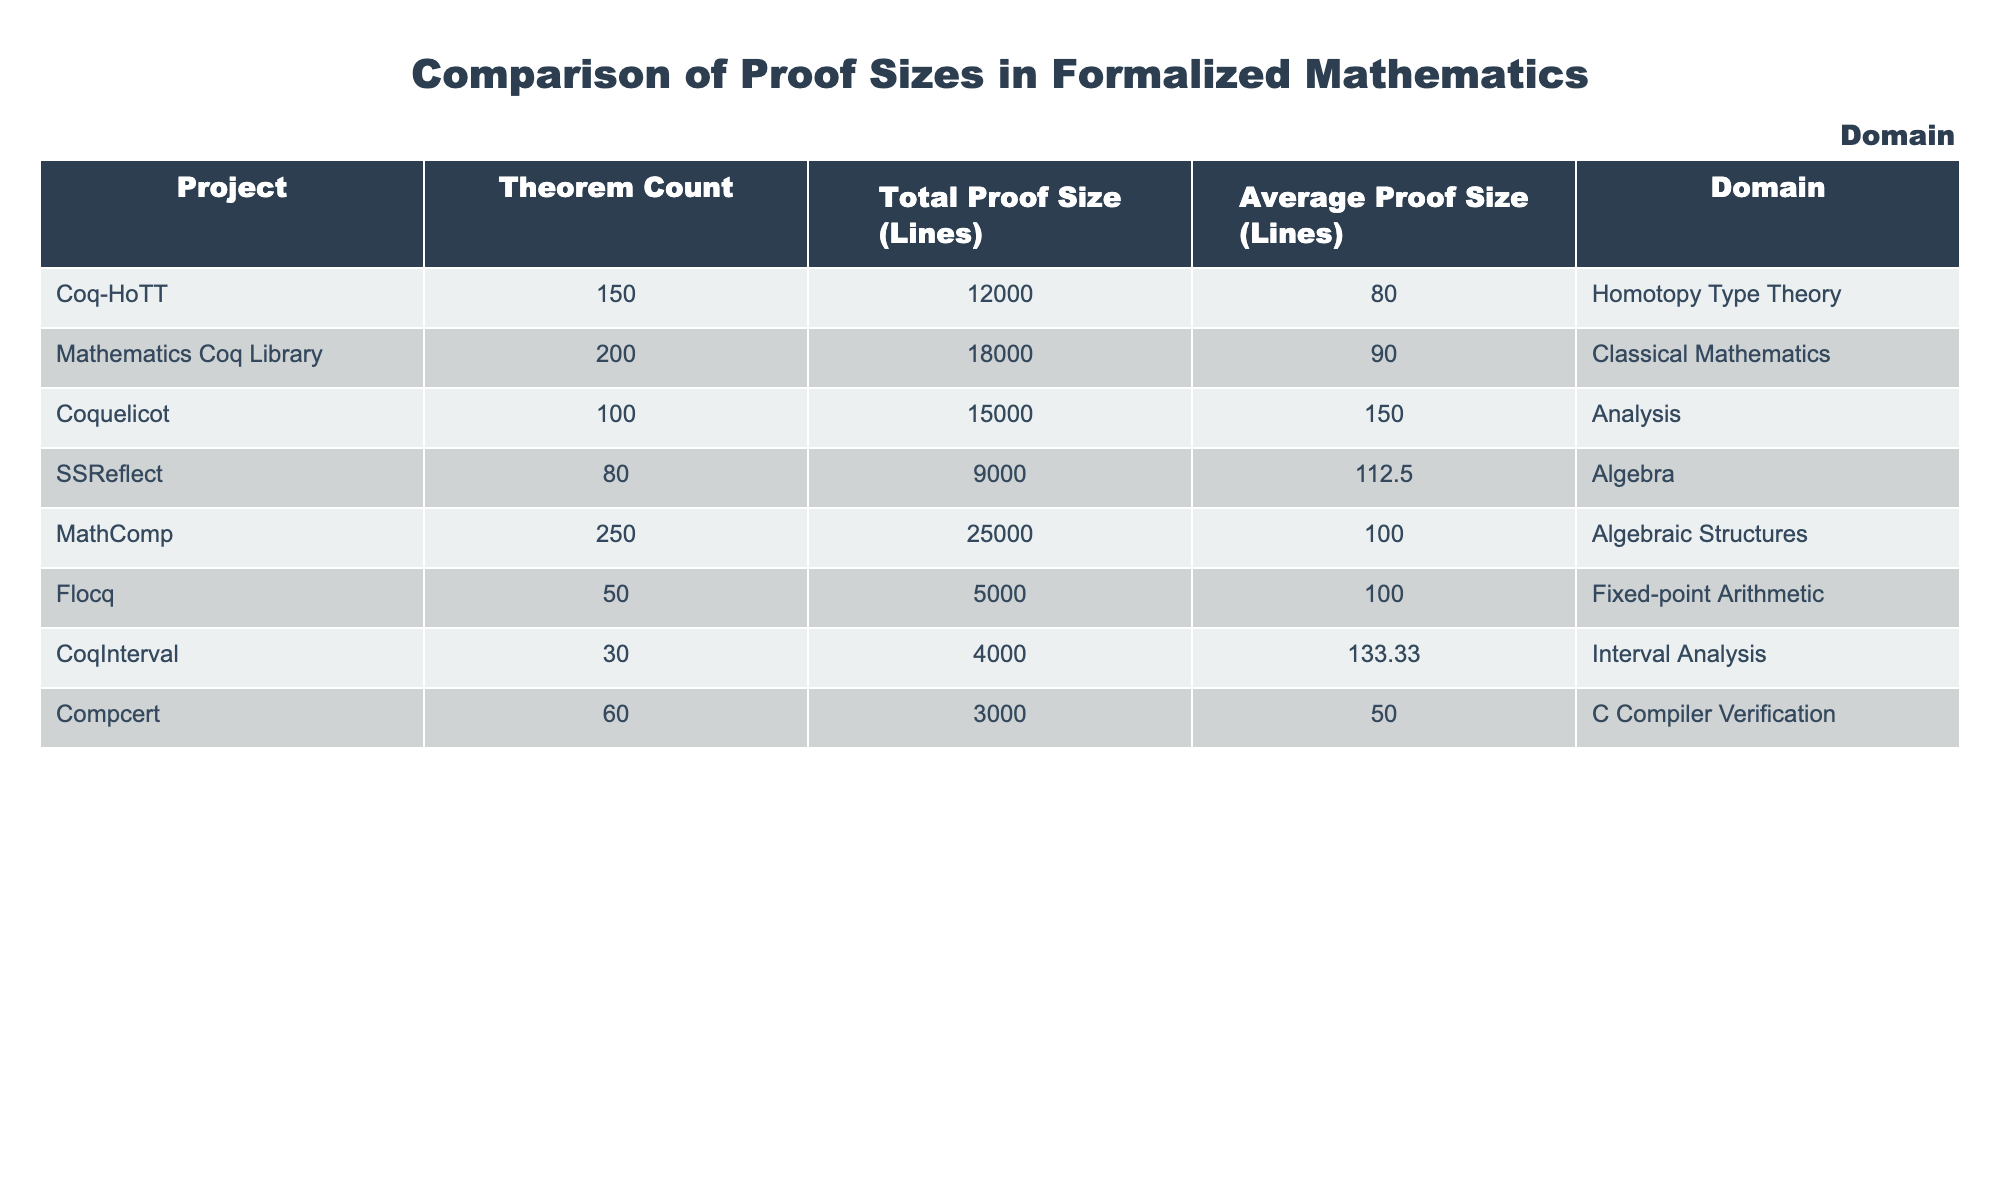What is the total proof size of the Mathematics Coq Library? The Mathematics Coq Library has a total proof size of 18000 lines, as directly listed in the table.
Answer: 18000 Which project has the highest average proof size? The average proof size for Coquelicot is 150 lines, which is higher than all other projects listed.
Answer: Coquelicot How many theorems are in the Coq-HoTT project? The Coq-HoTT project has 150 theorems, as indicated in the table.
Answer: 150 Is the average proof size of Flocq greater than 100 lines? The average proof size for Flocq is 100 lines, which is not greater than 100. Therefore, the answer is no.
Answer: No What is the total number of theorems across all projects in the algebra domain? MathComp has 250 theorems and SSReflect has 80 theorems, totaling 330 theorems in the algebra domain (250 + 80).
Answer: 330 Which project has the least total proof size? Compcert has the least total proof size at 3000 lines compared to all the other projects in the table.
Answer: Compcert What is the difference in average proof size between CoqInterval and Mathematics Coq Library? CoqInterval has an average proof size of 133.33 lines and Mathematics Coq Library has an average of 90 lines. The difference is 133.33 - 90 = 43.33 lines.
Answer: 43.33 How does the theorem count of Coq-HoTT compare to Compcert? Coq-HoTT has 150 theorems, while Compcert has 60 theorems. Thus, Coq-HoTT has more theorems (150 > 60).
Answer: Coq-HoTT has more theorems Is there a project in the table that has more than 200 theorems? Yes, MathComp has 250 theorems, which is indeed more than 200.
Answer: Yes 